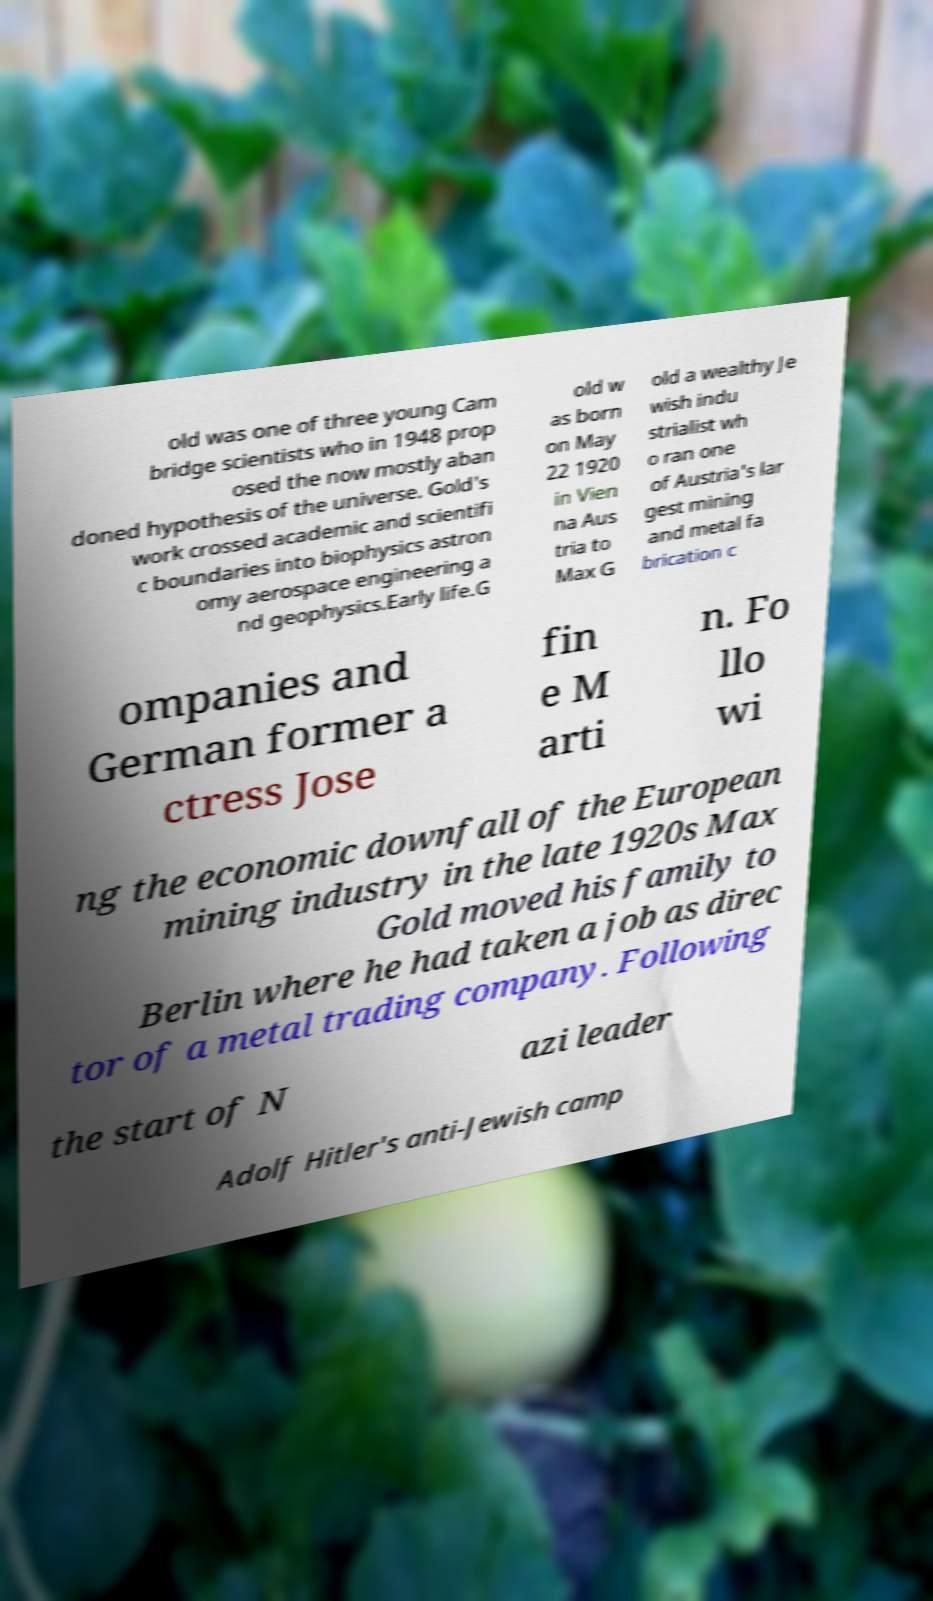For documentation purposes, I need the text within this image transcribed. Could you provide that? old was one of three young Cam bridge scientists who in 1948 prop osed the now mostly aban doned hypothesis of the universe. Gold's work crossed academic and scientifi c boundaries into biophysics astron omy aerospace engineering a nd geophysics.Early life.G old w as born on May 22 1920 in Vien na Aus tria to Max G old a wealthy Je wish indu strialist wh o ran one of Austria's lar gest mining and metal fa brication c ompanies and German former a ctress Jose fin e M arti n. Fo llo wi ng the economic downfall of the European mining industry in the late 1920s Max Gold moved his family to Berlin where he had taken a job as direc tor of a metal trading company. Following the start of N azi leader Adolf Hitler's anti-Jewish camp 